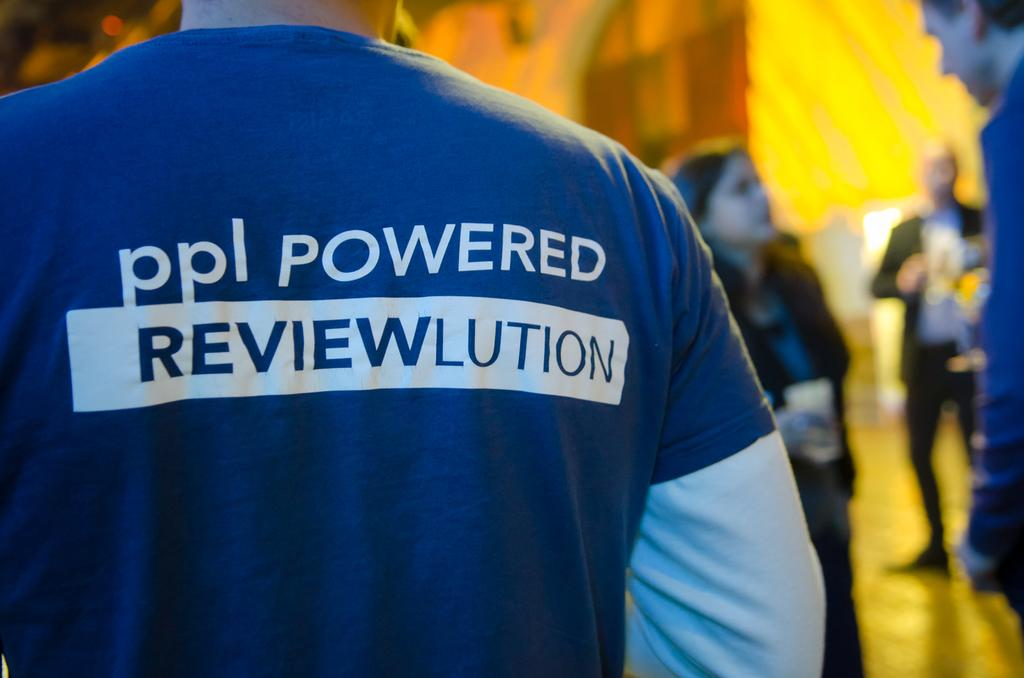<image>
Describe the image concisely. The back of a blue t-shirt displaying the words ppl Powered Reviewlution. 